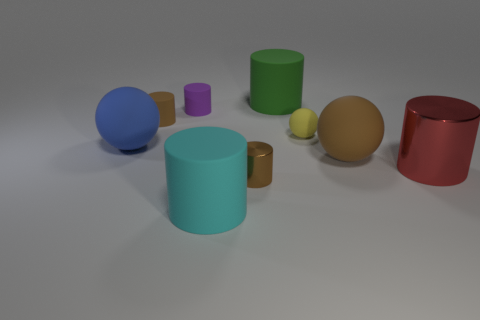Subtract all brown cylinders. How many cylinders are left? 4 Subtract all shiny cylinders. How many cylinders are left? 4 Subtract all green cylinders. Subtract all blue balls. How many cylinders are left? 5 Subtract all spheres. How many objects are left? 6 Subtract 0 blue cubes. How many objects are left? 9 Subtract all large green objects. Subtract all big rubber things. How many objects are left? 4 Add 2 big cyan cylinders. How many big cyan cylinders are left? 3 Add 9 tiny spheres. How many tiny spheres exist? 10 